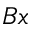Convert formula to latex. <formula><loc_0><loc_0><loc_500><loc_500>B x</formula> 